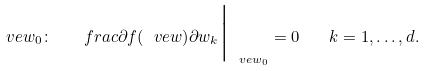<formula> <loc_0><loc_0><loc_500><loc_500>\ v e w _ { 0 } \colon \quad f r a c { \partial f ( \ v e w ) } { \partial w _ { k } } \Big | _ { \ v e w _ { 0 } } = 0 \quad k = 1 , \dots , d .</formula> 